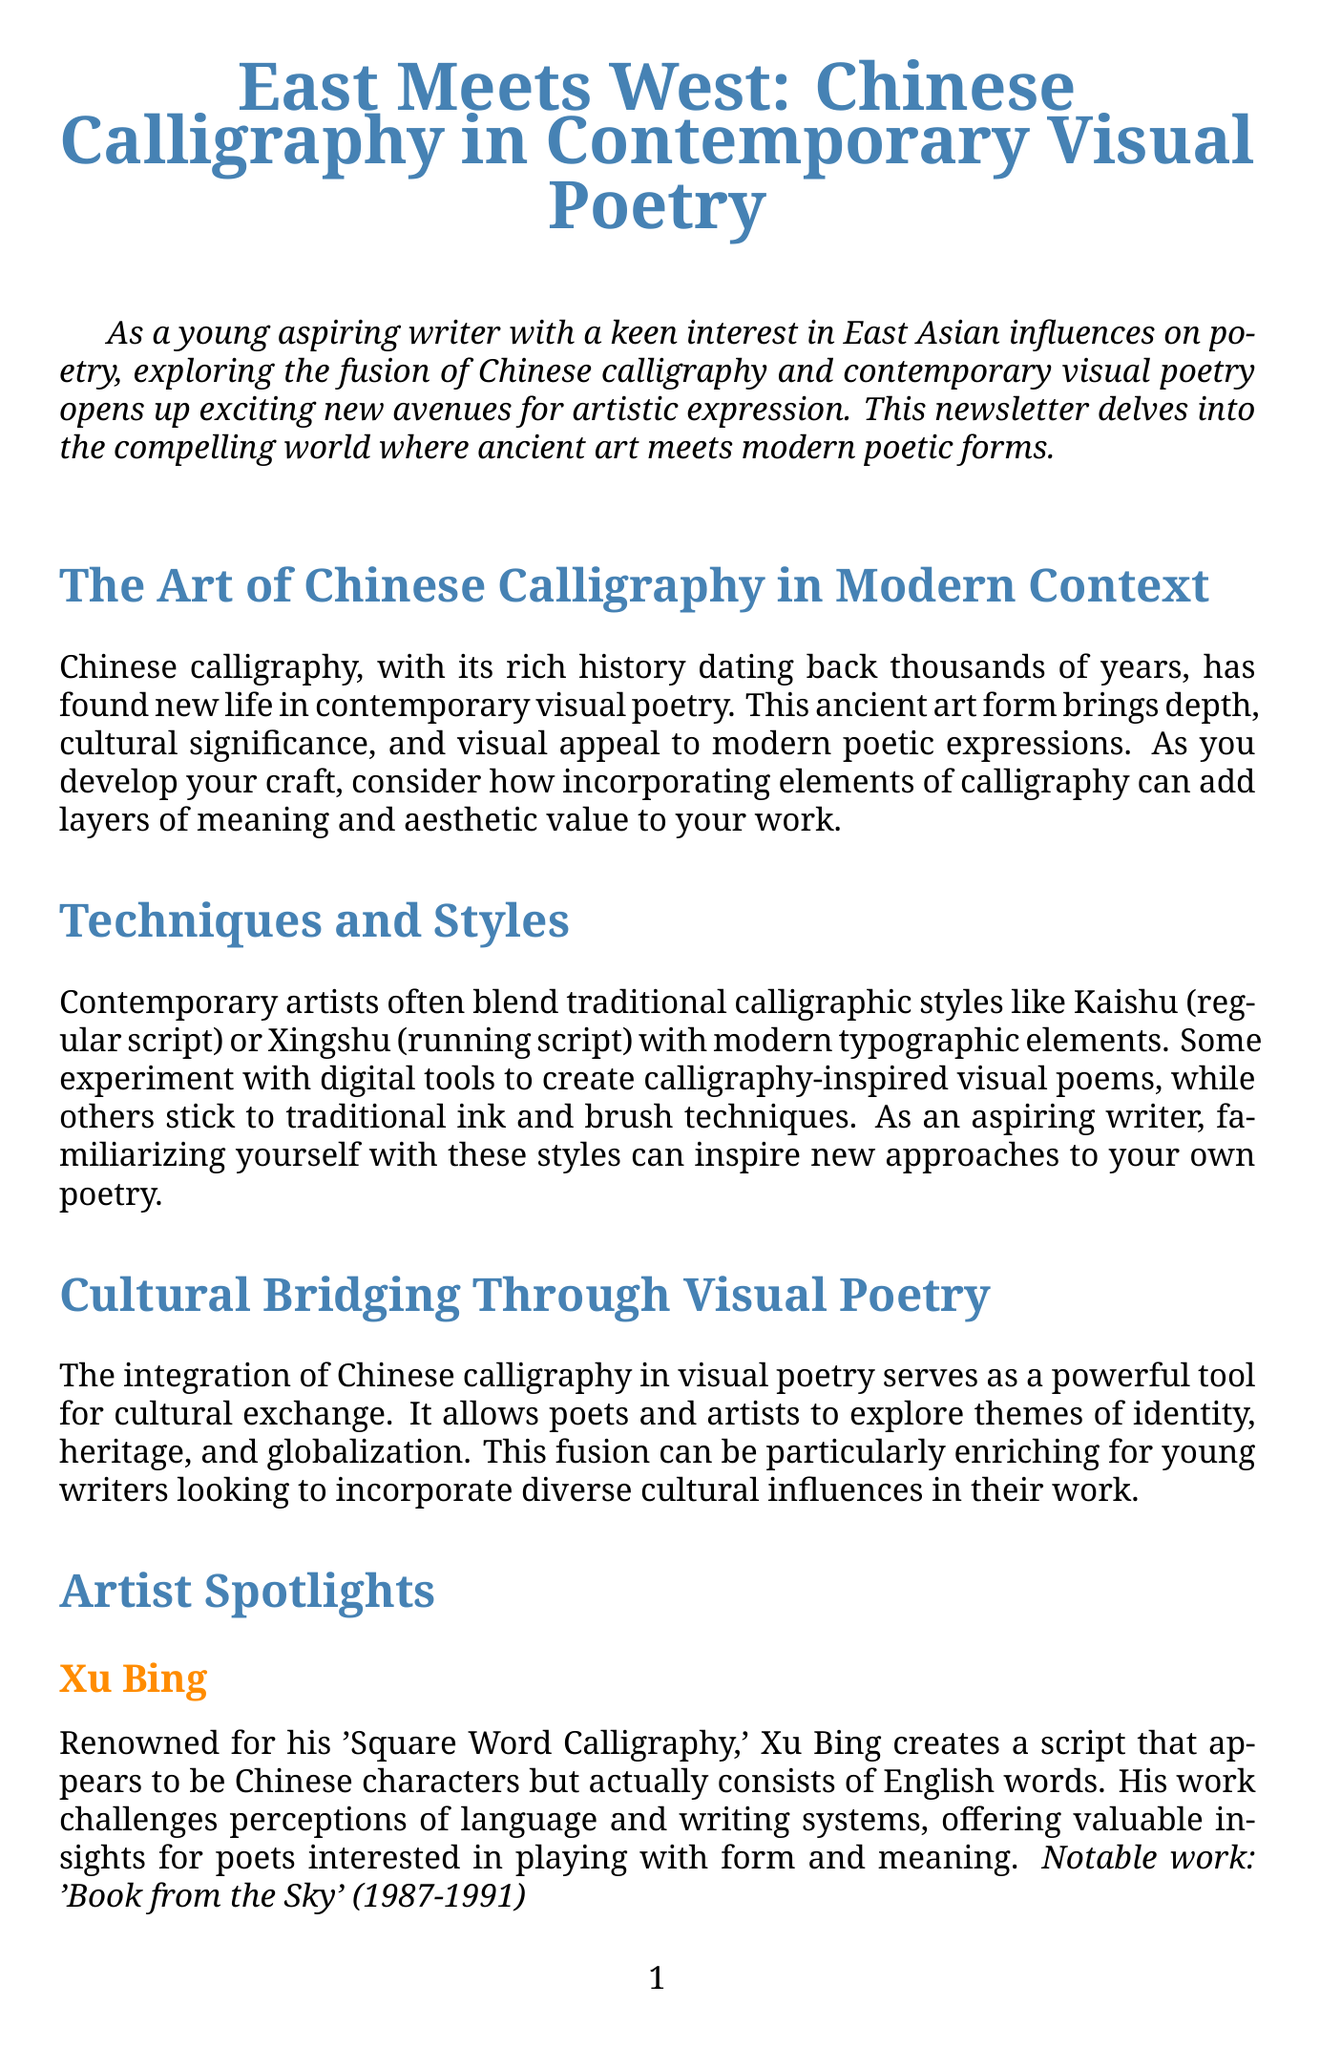What is the title of the newsletter? The title is provided at the beginning of the document and introduces the topic of the newsletter.
Answer: East Meets West: Chinese Calligraphy in Contemporary Visual Poetry Who is the artist known for 'Square Word Calligraphy'? This artist is highlighted in the artist spotlight section and is recognized for a unique approach to calligraphy.
Answer: Xu Bing What year was 'Book from the Sky' created? The notable work of Xu Bing is mentioned in the artist spotlight section along with the years it was created.
Answer: 1987-1991 Which course is offered by Coursera related to Chinese calligraphy? The resources section lists the course that provides insights into Chinese calligraphy.
Answer: Chinese Calligraphy: An Introduction What theme does Yau Bee Ling's work often explore? The description of Yau Bee Ling indicates the themes she addresses in her visual poetry.
Answer: Cultural identity and femininity How many artist spotlights are featured in the newsletter? The number of artists highlighted can be determined by counting the entries in the artist spotlight section.
Answer: Three What type of workshops does the ICCPS host? The resources section provides information about the nature of workshops offered by ICCPS.
Answer: Combining calligraphy and poetry In which country is artist Brody Neuenschwander based? The artist spotlight section includes the location of Brody Neuenschwander's artistic base.
Answer: Belgium What is the main purpose of integrating Chinese calligraphy into visual poetry? The document discusses the benefits of this integration in terms of cultural themes.
Answer: Cultural exchange 